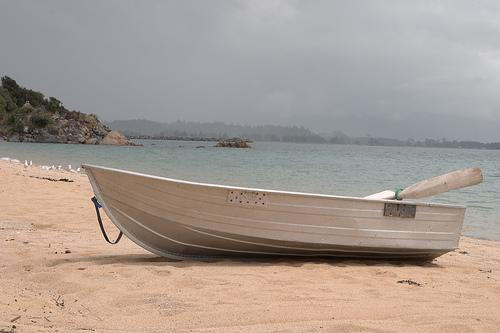What object can be found sticking out of the boat and what is it made of? An oar is sticking out of the boat, and it's made from wood. Provide a brief description of the sky and the beach in the image. The sky is gray and cloudy, while the beach is light brown and sandy. What type of scene is depicted in the image? Mention its main elements. This is a beach scene that includes a boat, an oar, seagulls, sand, and cloudy skies. Mention the color and material of the boat on the beach. The boat on the beach is silver and made from aluminum. What kind of land formation can be seen in the water, and what is it made of? A small rocky outcropping can be seen in the water, consisting of brown rocks. Name the types of debris found on the beach sand in the image. There are small sticks, seaweed, and other miscellaneous items scattered on the sandy beach. Can you identify any foliage in the image? If so, where is it located? Green trees can be seen on a rocky hillside near the water's edge. Comment on the position and activity of the seagulls in the scene. Seagulls are on the beach, likely searching for food or resting. What type of object is hanging down from the boat, and what color is it? A blue tether is hanging down from the aluminum canoe. Describe the appearance of the water in the ocean. The water in the ocean appears rough and blue. 